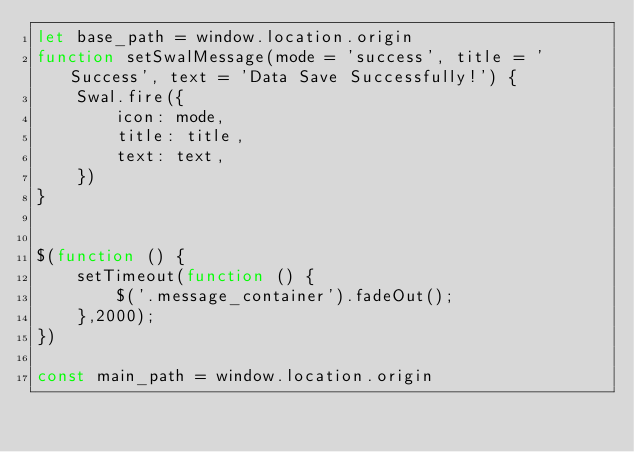<code> <loc_0><loc_0><loc_500><loc_500><_JavaScript_>let base_path = window.location.origin
function setSwalMessage(mode = 'success', title = 'Success', text = 'Data Save Successfully!') {
    Swal.fire({
        icon: mode,
        title: title,
        text: text,
    })
}


$(function () {
    setTimeout(function () {
        $('.message_container').fadeOut();
    },2000);
})

const main_path = window.location.origin
</code> 